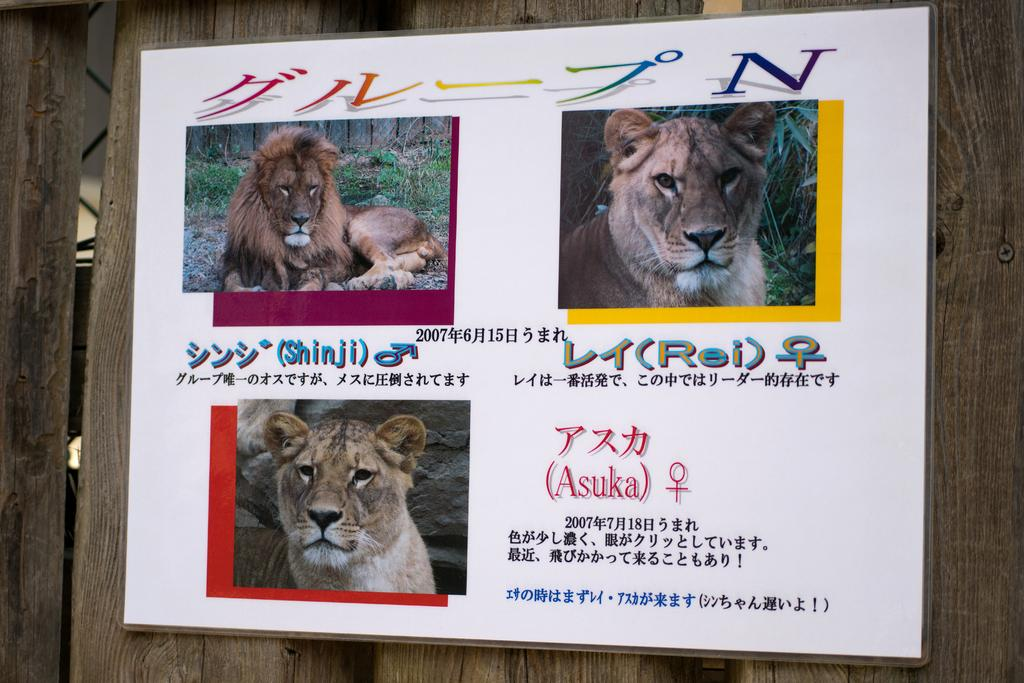Where is the poster located in the image? The poster is on a wooden railing in the image. What type of images are featured on the poster? The poster contains pictures of lions and trees. Is there any text on the poster? Yes, there is text on the poster. Can you see a child attempting to use a rake on the poster? No, there is no child or rake present on the poster. The poster contains pictures of lions and trees, along with text. 